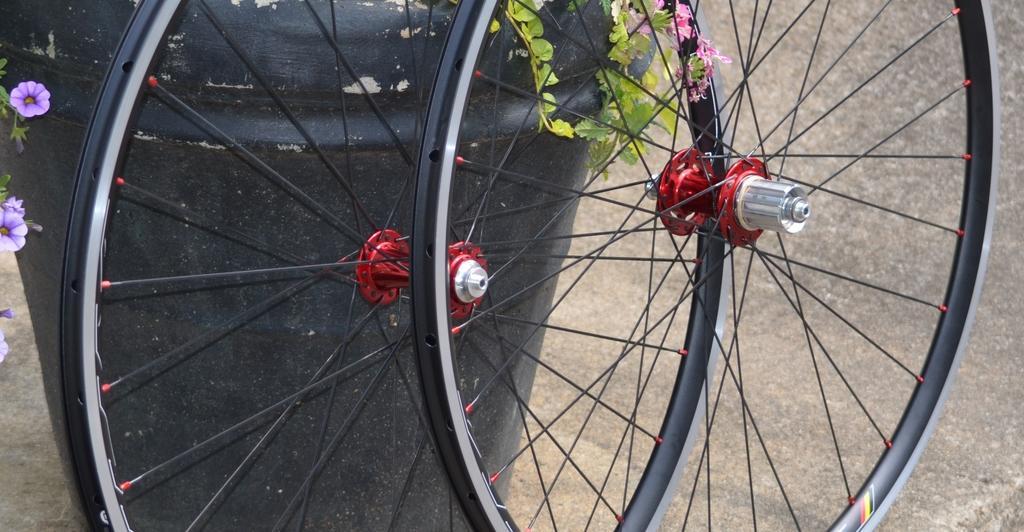Please provide a concise description of this image. In the image we can see there are wheels kept on the ground and behind there is a black colour drum. There are flowers on the plant. 